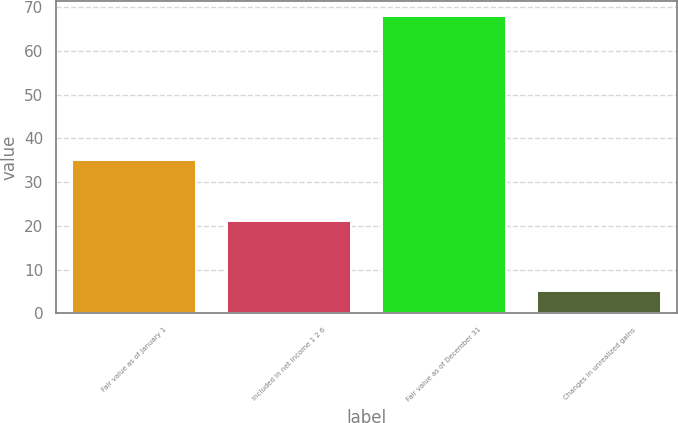Convert chart to OTSL. <chart><loc_0><loc_0><loc_500><loc_500><bar_chart><fcel>Fair value as of January 1<fcel>Included in net income 1 2 6<fcel>Fair value as of December 31<fcel>Changes in unrealized gains<nl><fcel>35<fcel>21<fcel>68<fcel>5<nl></chart> 